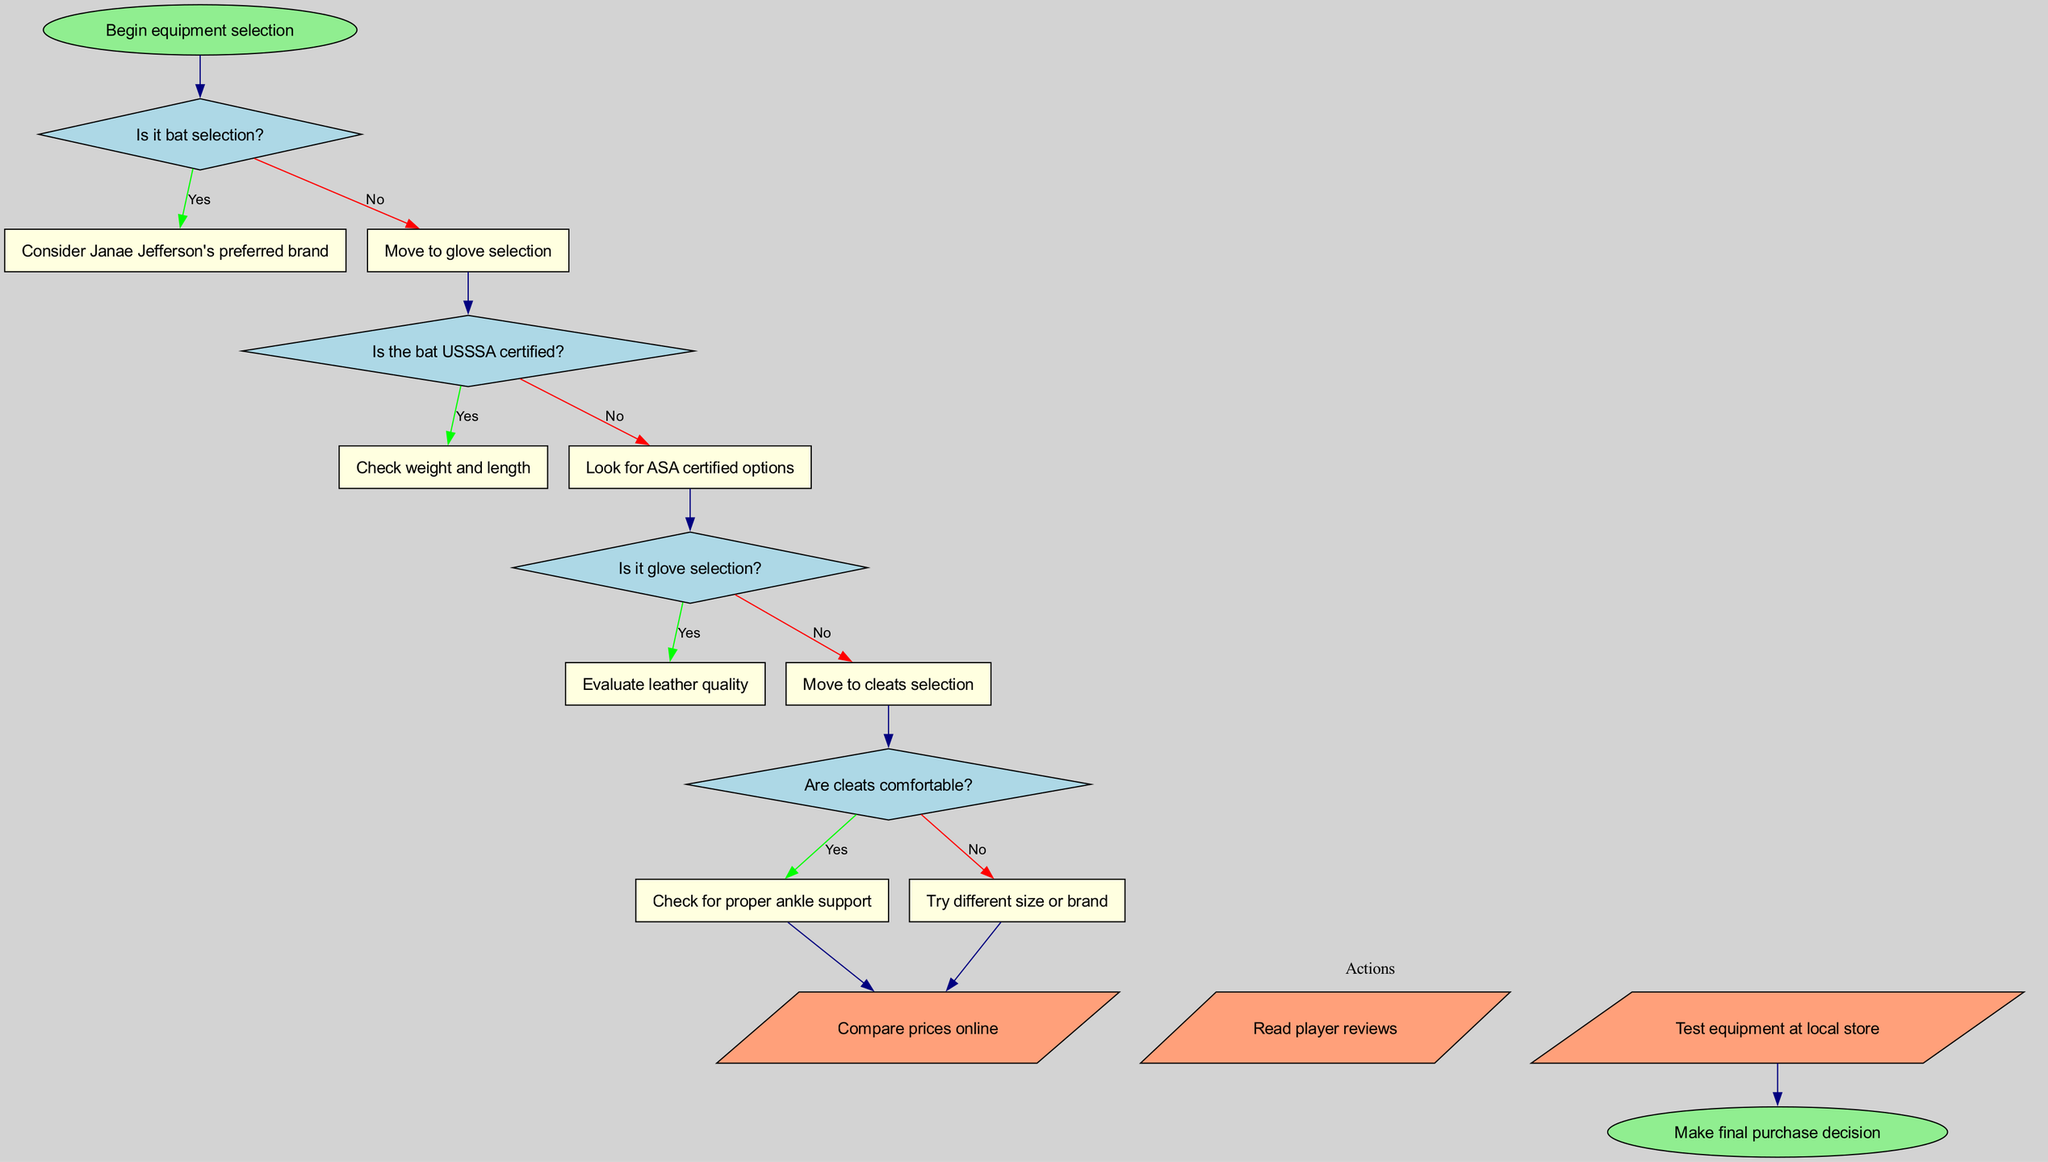What is the starting point of this flowchart? The starting point of the flowchart is the node labeled "Begin equipment selection," which initiates the decision-making process.
Answer: Begin equipment selection How many decision nodes are present in the diagram? The diagram contains four decision nodes, each representing a question that guides the equipment selection process.
Answer: 4 What is the first question in the decision process? The first question asked is "Is it bat selection?" which determines the next step based on whether the selection is related to bats or not.
Answer: Is it bat selection? What follows if the answer to "Is it bat selection?" is yes? If the answer to the question is yes, the flowchart indicates to "Consider Janae Jefferson's preferred brand" as the next step in the equipment selection process.
Answer: Consider Janae Jefferson's preferred brand What action node directly follows the last decision node? The action node that directly follows the last decision node is labeled "Compare prices online," which suggests a step to take before making the final purchase.
Answer: Compare prices online If the cleats are not comfortable, what is the next action to be taken? If the cleats are found to be uncomfortable, the flowchart directs to "Try different size or brand," indicating a necessary adjustment to find suitable cleats.
Answer: Try different size or brand What happens after checking whether the bat is USSSA certified? After checking for USSSA certification, if the bat is not certified, the flowchart advises to "Look for ASA certified options," indicating an alternative choice in bat selection.
Answer: Look for ASA certified options What is the final step of this flowchart? The final step of the flowchart is "Make final purchase decision," which concludes the decision-making process after all necessary evaluations and actions.
Answer: Make final purchase decision What type of node represents the questions in this flowchart? The questions in the flowchart are represented by diamond-shaped nodes, which indicate decision points requiring a yes or no answer.
Answer: Diamond-shaped nodes 